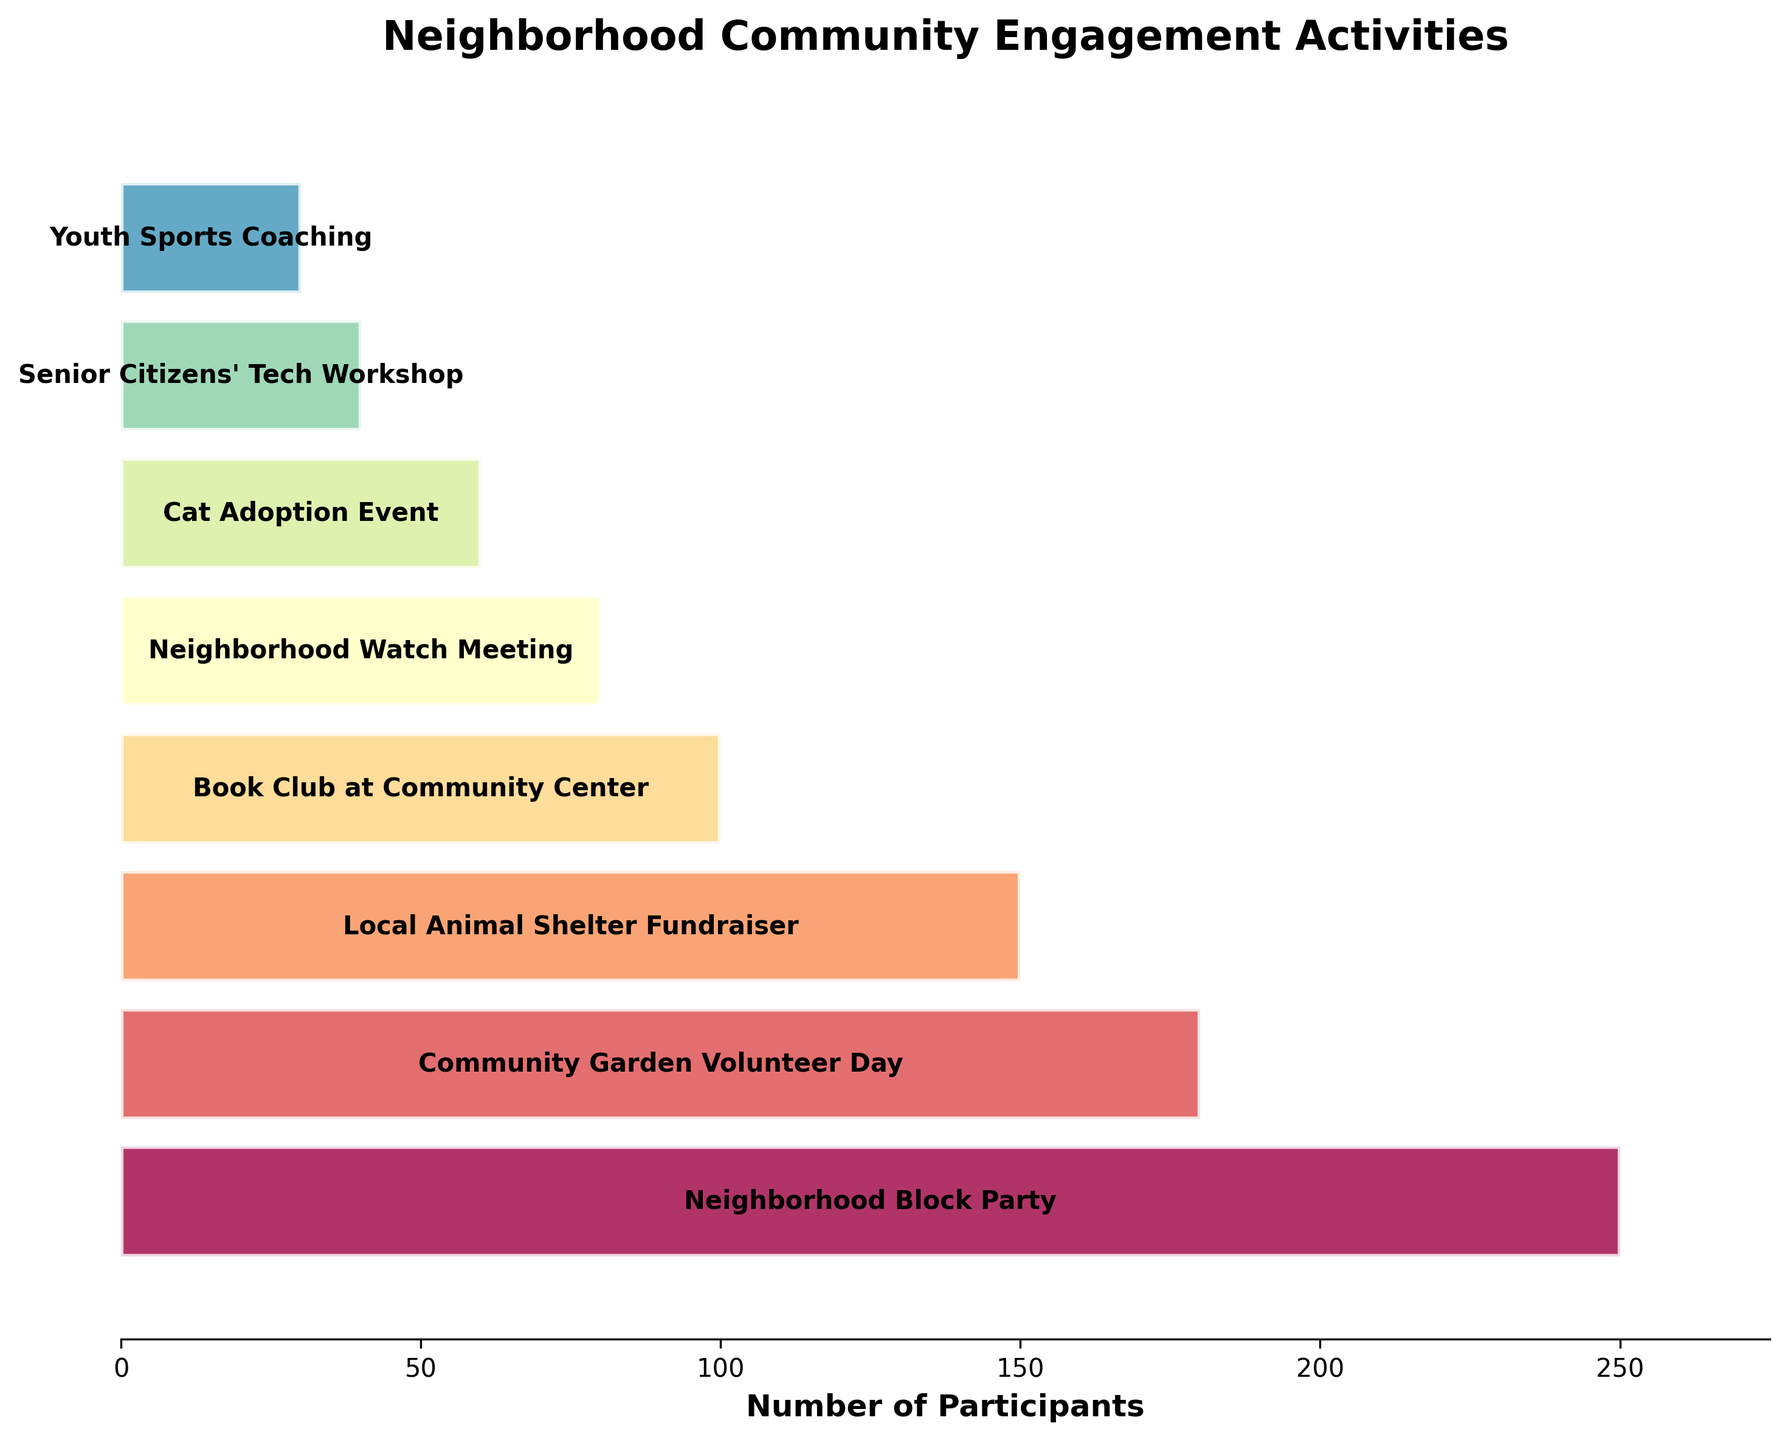What is the title of the funnel chart? The title of the funnel chart is displayed prominently at the top of the figure.
Answer: Neighborhood Community Engagement Activities How many activities are listed in the chart? Count the number of horizontal bars, each representing an activity.
Answer: 8 Which activity had the highest number of participants? Look at the topmost horizontal bar, as the activities are sorted from most to least popular.
Answer: Neighborhood Block Party What's the difference in the number of participants between the Neighborhood Block Party and the Cat Adoption Event? Subtract the number of participants in the Cat Adoption Event from the number in the Neighborhood Block Party (250 - 60).
Answer: 190 How many more participants attended the Local Animal Shelter Fundraiser compared to the Senior Citizens' Tech Workshop? Subtract the number of participants in the Senior Citizens' Tech Workshop from those in the Local Animal Shelter Fundraiser (150 - 40).
Answer: 110 Which activities have fewer than 100 participants? Identify activities from the chart that have their participant numbers listed below 100.
Answer: Neighborhood Watch Meeting, Cat Adoption Event, Senior Citizens' Tech Workshop, Youth Sports Coaching What is the average number of participants across all the activities? Sum the participant numbers for all activities and divide by the total number of activities ((250 + 180 + 150 + 100 + 80 + 60 + 40 + 30) / 8).
Answer: 111.25 What is the combined number of participants for the Community Garden Volunteer Day and the Book Club at Community Center? Add the number of participants for both activities (180 + 100).
Answer: 280 Which activity had the least number of participants, and how many participants were there? Look at the bottommost bar on the funnel chart which represents the least popular activity.
Answer: Youth Sports Coaching, 30 Is the number of participants in the Neighborhood Watch Meeting greater than that in the Cat Adoption Event? Compare the participant numbers for both activities (80 for Neighborhood Watch Meeting vs. 60 for Cat Adoption Event).
Answer: Yes 